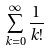<formula> <loc_0><loc_0><loc_500><loc_500>\sum _ { k = 0 } ^ { \infty } \frac { 1 } { k ! }</formula> 